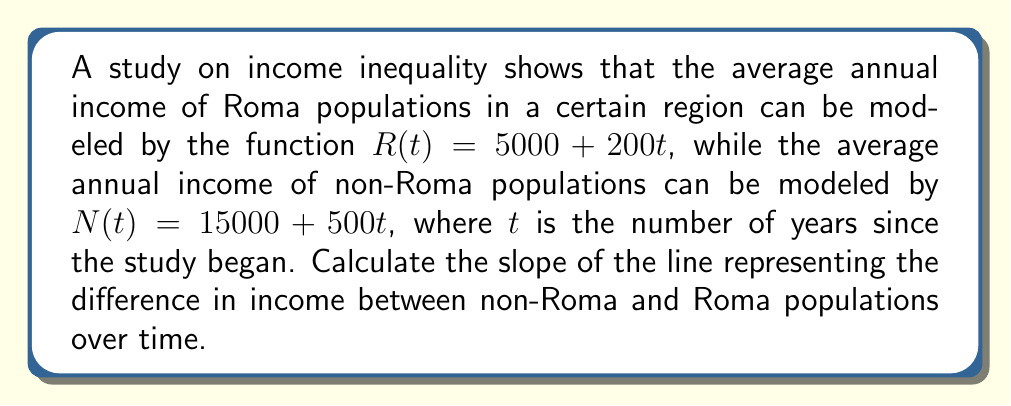Help me with this question. 1) First, we need to find the function that represents the difference in income between non-Roma and Roma populations:
   $D(t) = N(t) - R(t)$

2) Substitute the given functions:
   $D(t) = (15000 + 500t) - (5000 + 200t)$

3) Simplify:
   $D(t) = 15000 + 500t - 5000 - 200t$
   $D(t) = 10000 + 300t$

4) The function $D(t) = 10000 + 300t$ is a linear function in the form $y = mx + b$, where:
   $m$ is the slope
   $b$ is the y-intercept

5) In this case:
   $m = 300$
   $b = 10000$

6) The slope of the line represents the rate of change of the income difference over time.

Therefore, the slope of the line representing the difference in income between non-Roma and Roma populations over time is 300.
Answer: 300 